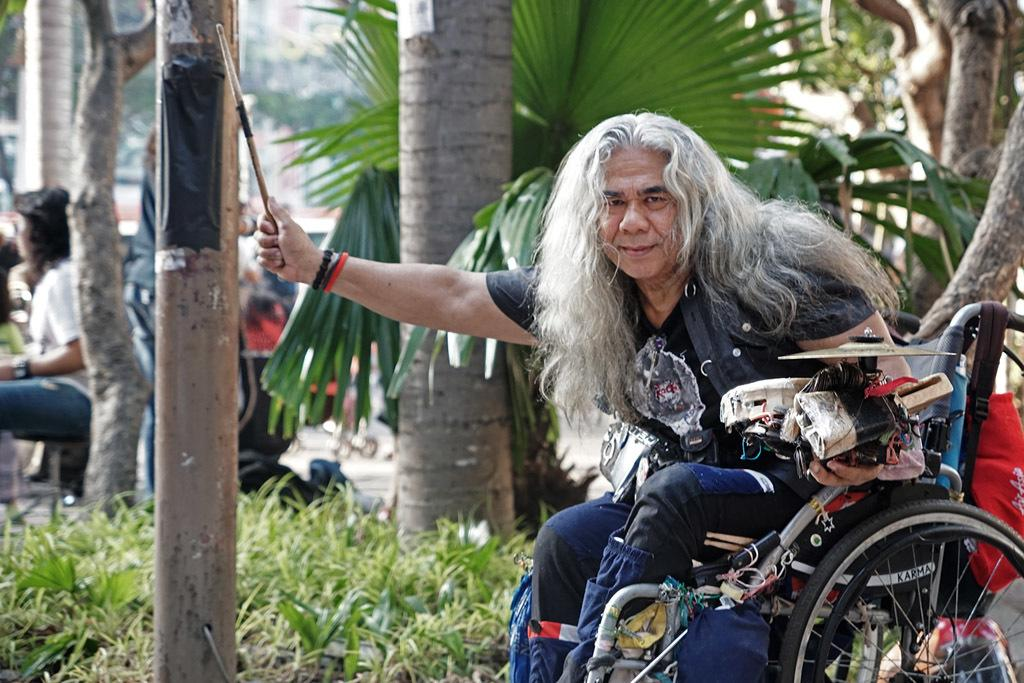What is the main subject of the image? There is a person sitting on a wheelchair in the image. What type of natural environment is visible in the image? There are trees and grass in the image. Can you describe the people in the background of the image? There are people in the background of the image. What is the price of the bike in the image? There is no bike present in the image, so it is not possible to determine its price. How many frogs can be seen in the image? There are no frogs visible in the image. 